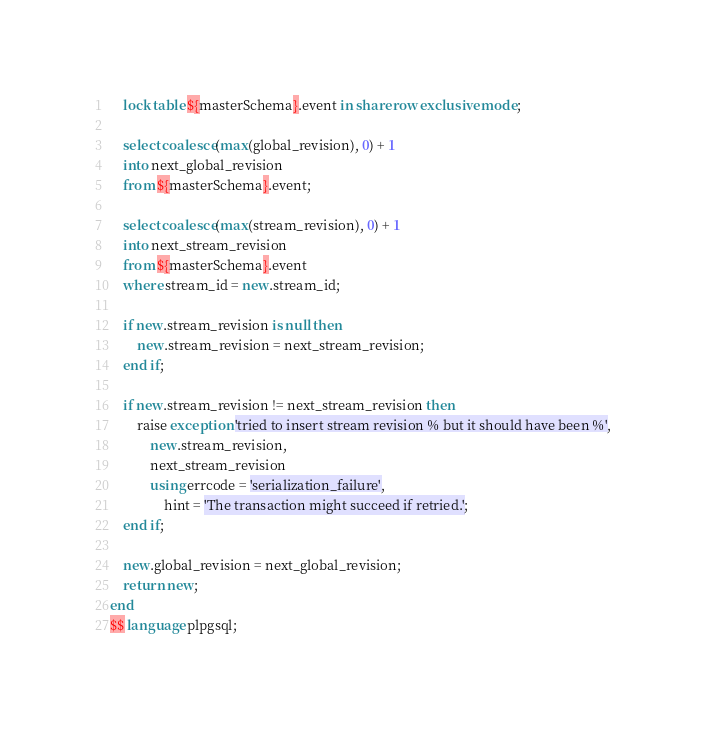Convert code to text. <code><loc_0><loc_0><loc_500><loc_500><_SQL_>    lock table ${masterSchema}.event in share row exclusive mode;

    select coalesce(max(global_revision), 0) + 1
    into next_global_revision
    from ${masterSchema}.event;

    select coalesce(max(stream_revision), 0) + 1
    into next_stream_revision
    from ${masterSchema}.event
    where stream_id = new.stream_id;

    if new.stream_revision is null then
        new.stream_revision = next_stream_revision;
    end if;

    if new.stream_revision != next_stream_revision then
        raise exception 'tried to insert stream revision % but it should have been %',
            new.stream_revision,
            next_stream_revision
            using errcode = 'serialization_failure',
                hint = 'The transaction might succeed if retried.';
    end if;

    new.global_revision = next_global_revision;
    return new;
end
$$ language plpgsql;
</code> 